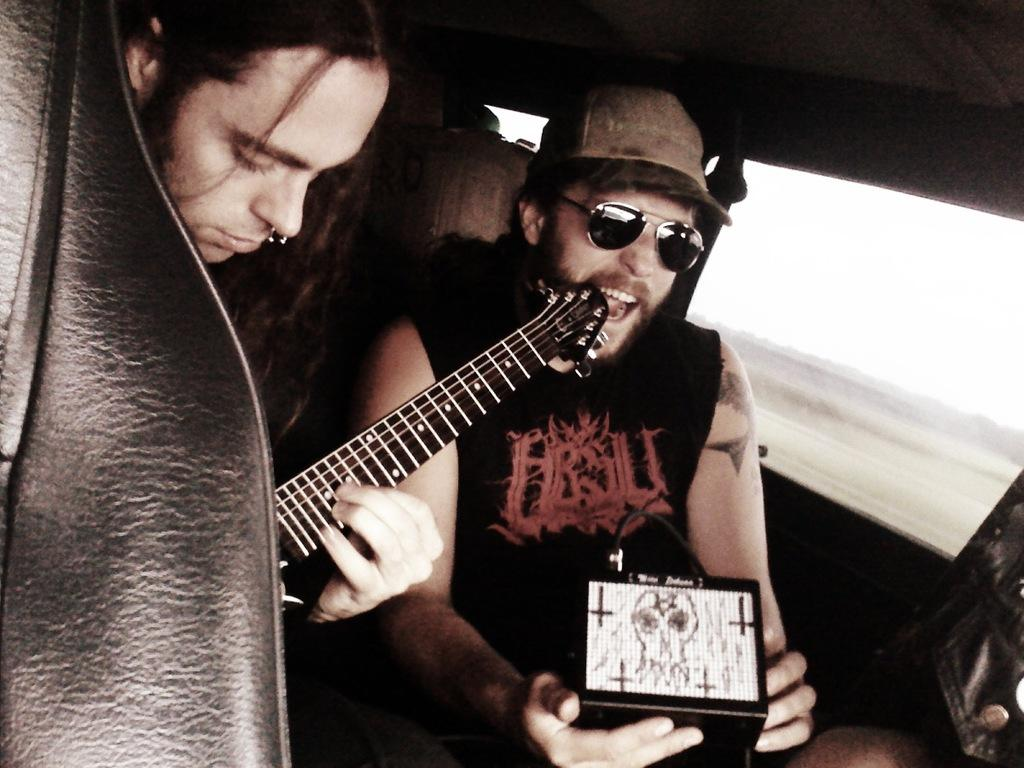How many people are in the vehicle in the image? There are two people in the vehicle in the image. What is one of the people holding? One of the people is holding a guitar. Can you describe the appearance of the other person? The other person is wearing spectacles and a hat. What can be seen in the background of the image? There is sky and land visible in the background. What type of bat is flying in the image? There is no bat present in the image; it only features two people in a vehicle and the background. 